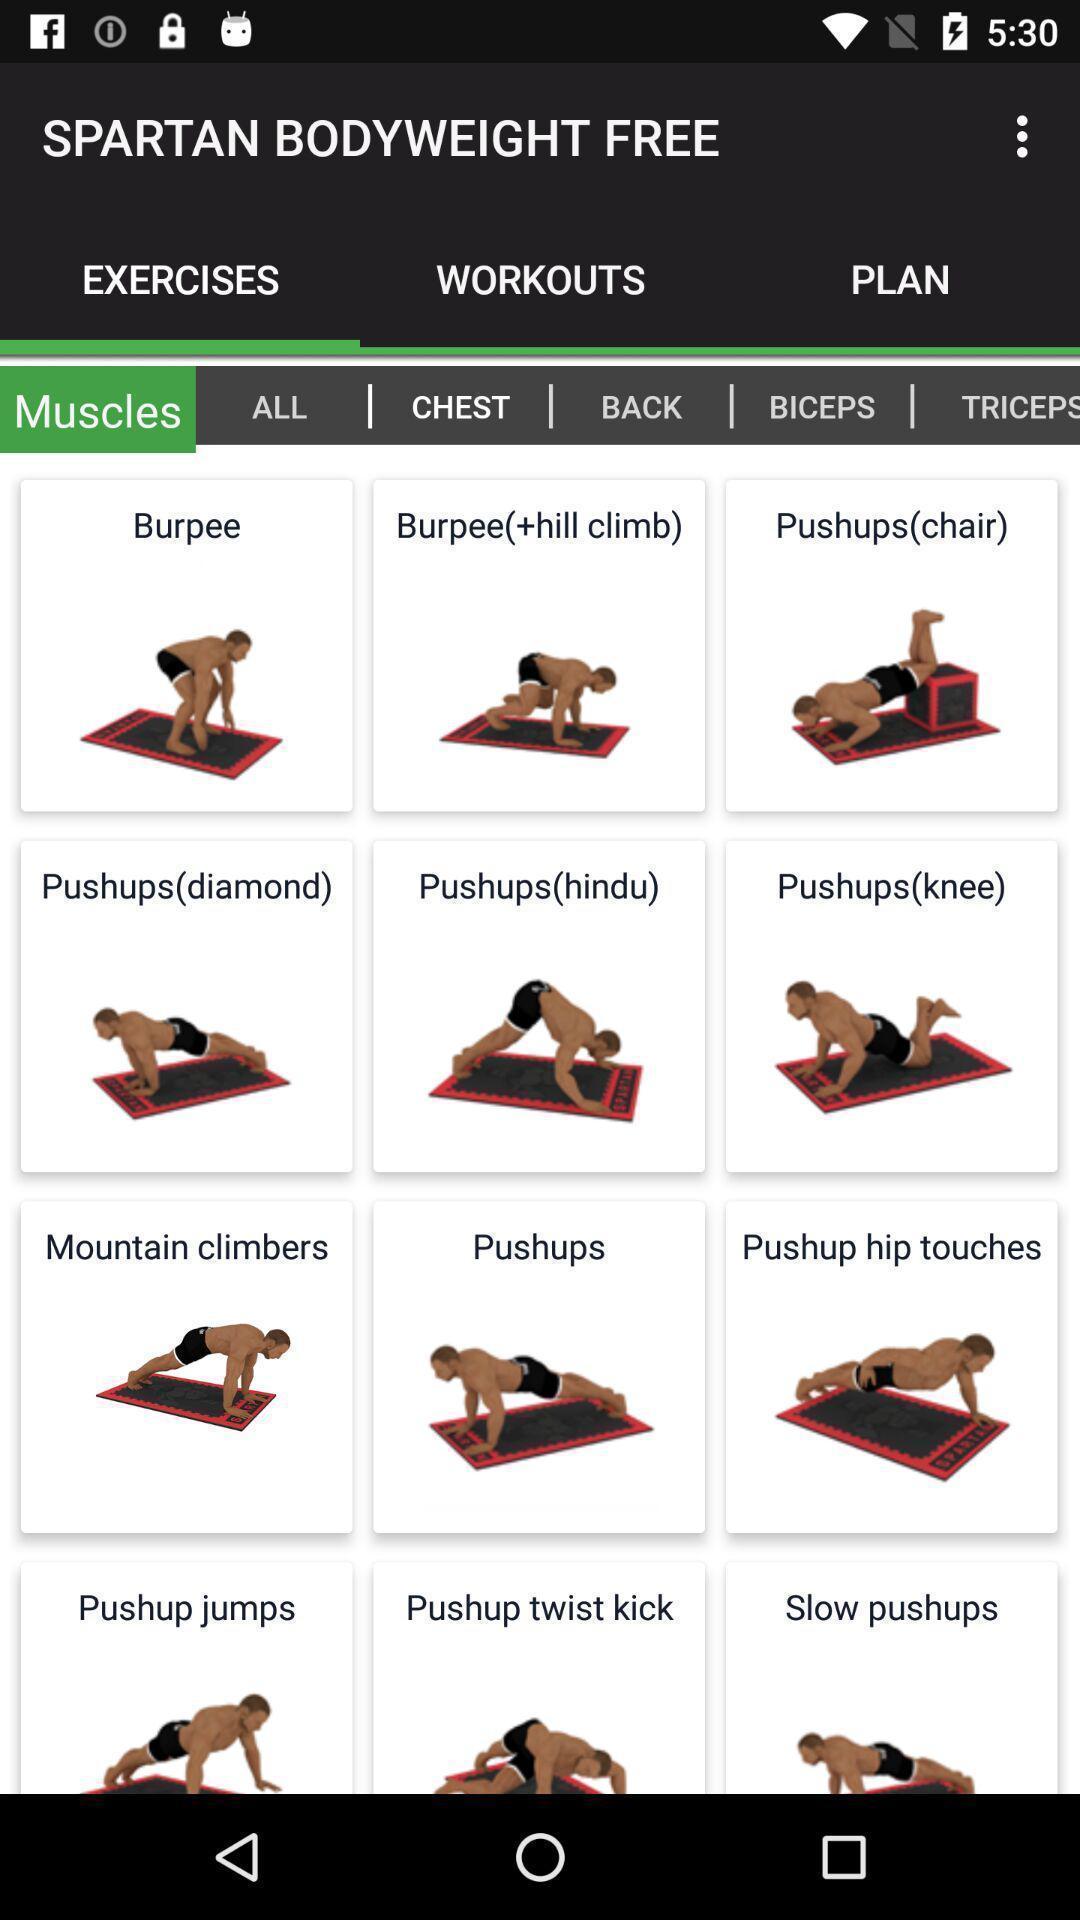Give me a narrative description of this picture. Results for exercise and muscles in an fitness application. 